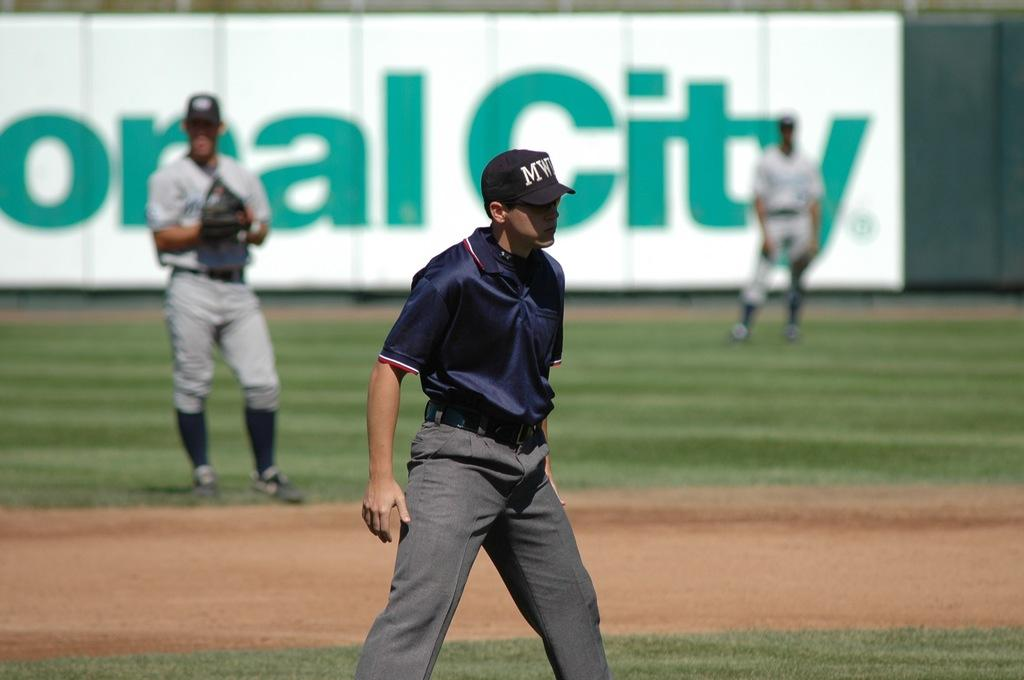<image>
Present a compact description of the photo's key features. A man on a baseball diamond wears a baseball cap with the initials MW on it. 